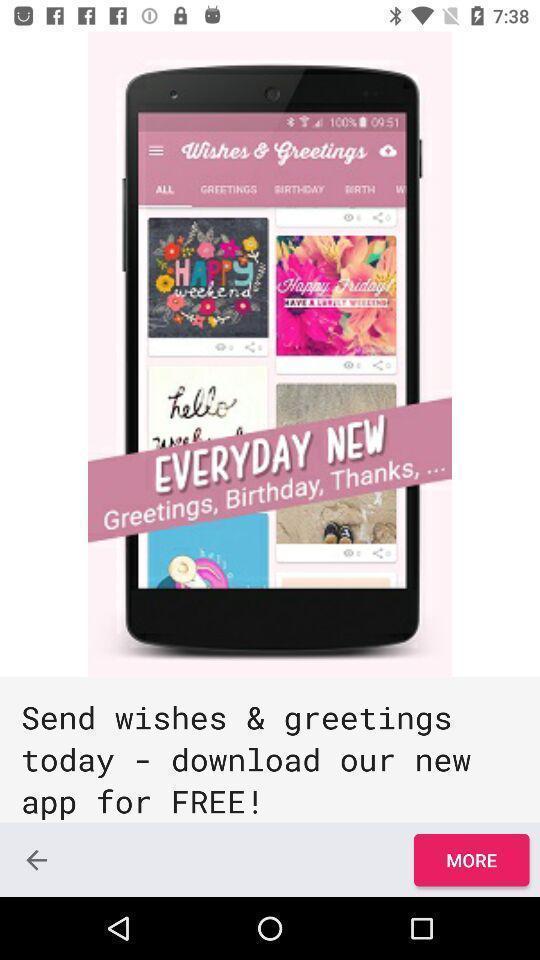What is the overall content of this screenshot? Page showing information about app and more. 